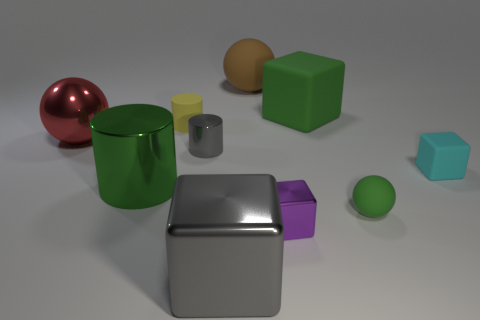What material is the tiny ball that is the same color as the large cylinder?
Your response must be concise. Rubber. Is the color of the small metal cylinder the same as the large cube that is in front of the big green metallic object?
Your response must be concise. Yes. How many other things are the same color as the big metal block?
Your answer should be compact. 1. There is a gray object that is the same material as the gray cylinder; what shape is it?
Your response must be concise. Cube. What is the color of the tiny metallic thing that is in front of the green object in front of the large green thing that is left of the green matte cube?
Offer a terse response. Purple. Are there fewer red shiny balls in front of the tiny cyan cube than small matte things that are left of the tiny purple shiny object?
Provide a succinct answer. Yes. Does the small gray object have the same shape as the small purple thing?
Provide a short and direct response. No. What number of purple rubber spheres have the same size as the cyan matte cube?
Give a very brief answer. 0. Are there fewer metal things behind the tiny yellow rubber cylinder than tiny gray matte cubes?
Your answer should be compact. No. There is a green matte thing that is in front of the cylinder that is in front of the small metallic cylinder; how big is it?
Offer a terse response. Small. 